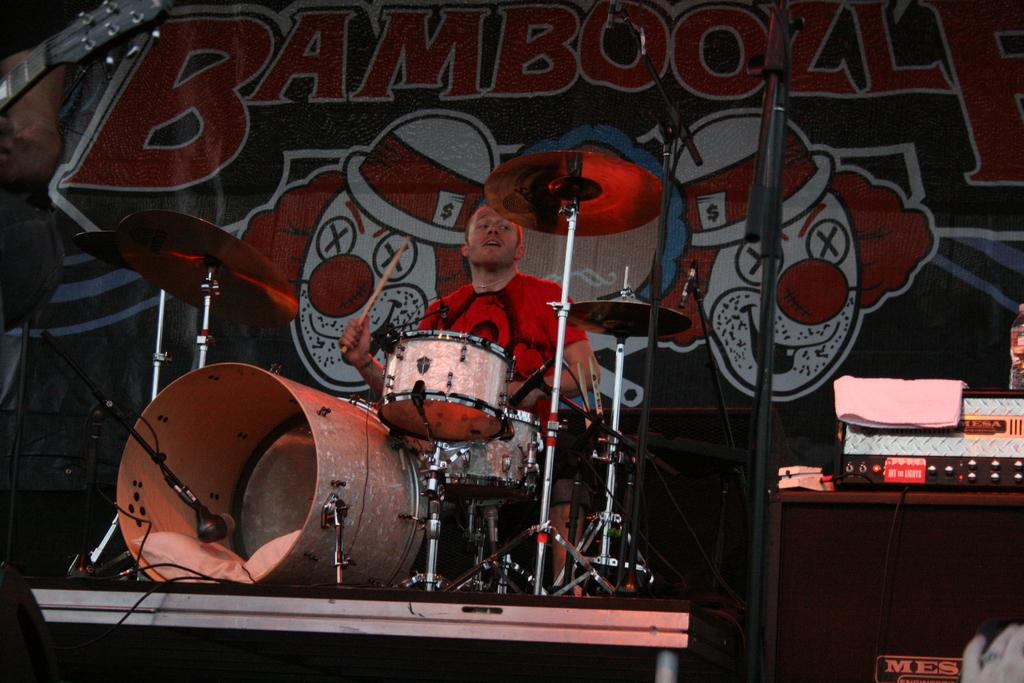What is the person in the image doing? The person is playing a musical instrument in the image. What else can be seen in the image besides the person playing the instrument? Cables, microphones (mics) on mic stands, and speakers are visible in the image. What is the purpose of the microphones and speakers in the image? The microphones and speakers are likely used for amplifying sound during a performance or event. What is on the wall in the background of the image? There is an advertisement on the wall in the background of the image. How many bells are hanging from the ceiling in the image? There are no bells visible in the image. What type of scale is being used to weigh the instruments in the image? There is no scale present in the image, and the instruments are not being weighed. 